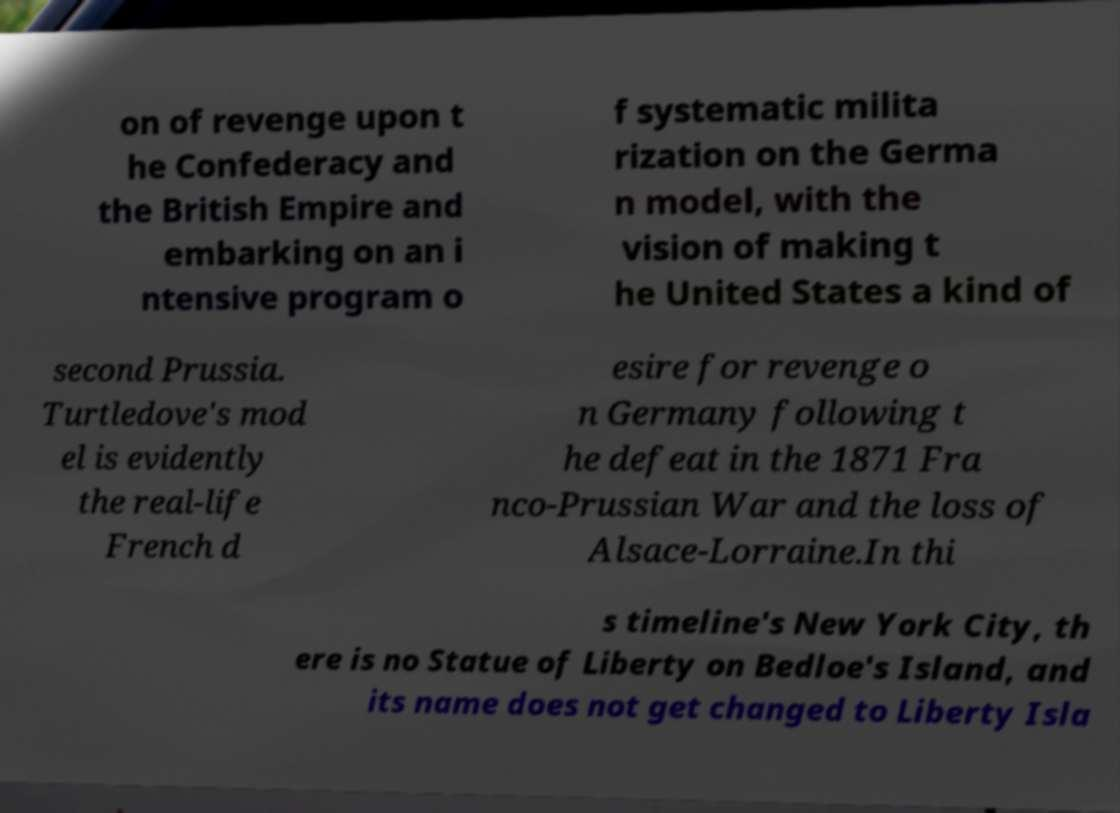Could you assist in decoding the text presented in this image and type it out clearly? on of revenge upon t he Confederacy and the British Empire and embarking on an i ntensive program o f systematic milita rization on the Germa n model, with the vision of making t he United States a kind of second Prussia. Turtledove's mod el is evidently the real-life French d esire for revenge o n Germany following t he defeat in the 1871 Fra nco-Prussian War and the loss of Alsace-Lorraine.In thi s timeline's New York City, th ere is no Statue of Liberty on Bedloe's Island, and its name does not get changed to Liberty Isla 